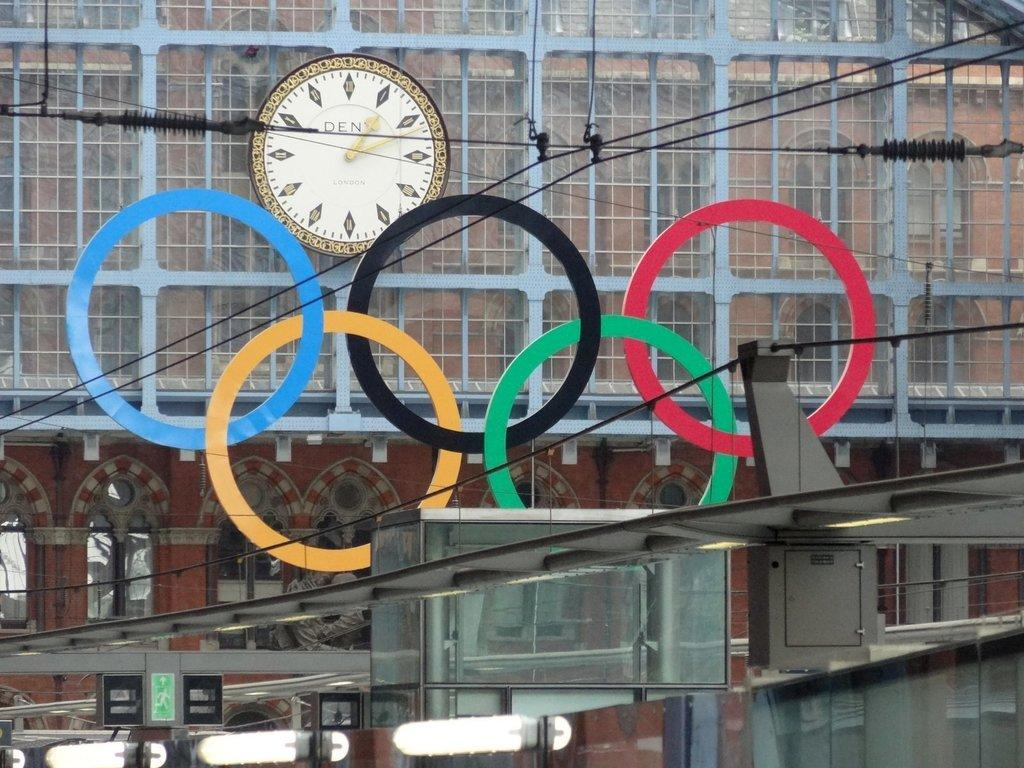<image>
Summarize the visual content of the image. Olympic rings decorate a building with a clock that says DEN on it. 